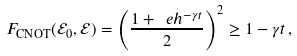Convert formula to latex. <formula><loc_0><loc_0><loc_500><loc_500>F _ { \text {CNOT} } ( \mathcal { E } _ { 0 } , \mathcal { E } ) = \left ( \frac { 1 + \ e h ^ { - \gamma t } } { 2 } \right ) ^ { 2 } \geq 1 - \gamma t \, ,</formula> 